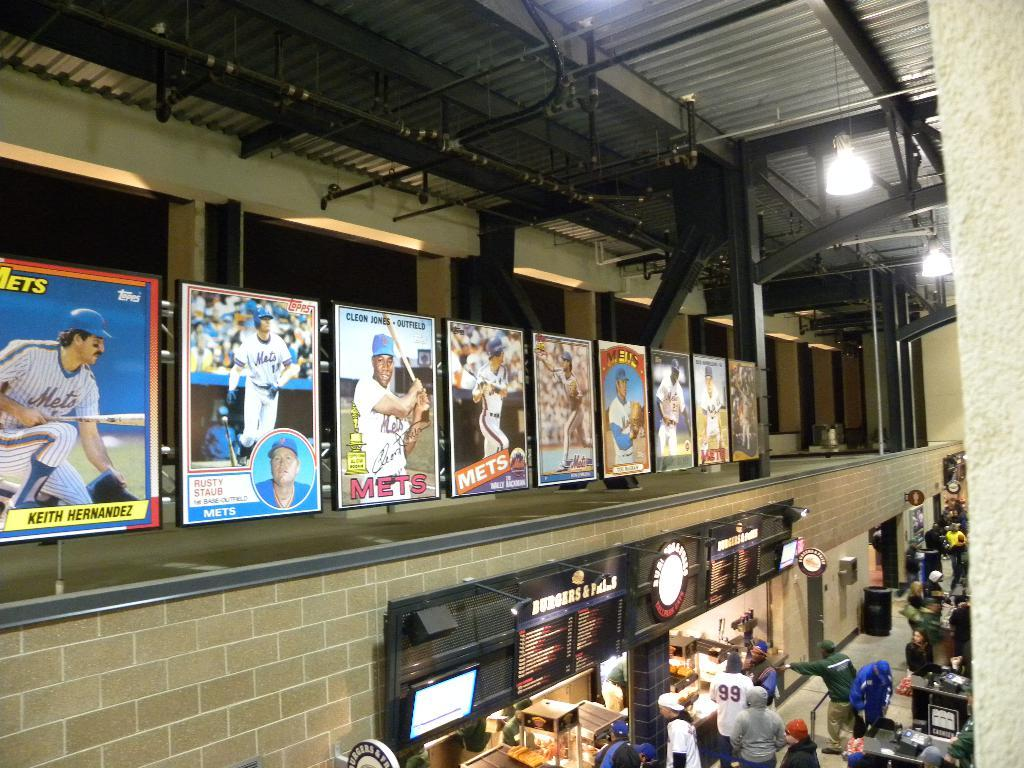<image>
Give a short and clear explanation of the subsequent image. A cafeteria area with the ceiling showing and on the wall a line of large baseball cards with for MET players. 